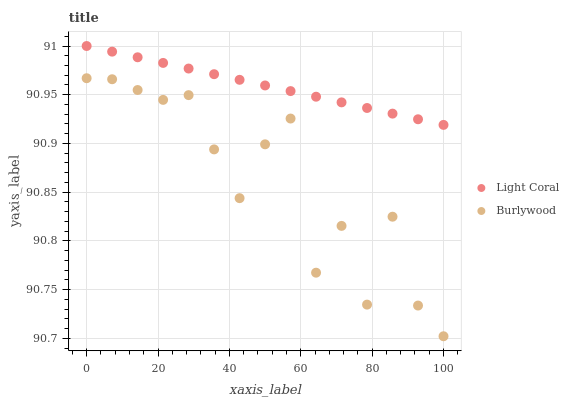Does Burlywood have the minimum area under the curve?
Answer yes or no. Yes. Does Light Coral have the maximum area under the curve?
Answer yes or no. Yes. Does Burlywood have the maximum area under the curve?
Answer yes or no. No. Is Light Coral the smoothest?
Answer yes or no. Yes. Is Burlywood the roughest?
Answer yes or no. Yes. Is Burlywood the smoothest?
Answer yes or no. No. Does Burlywood have the lowest value?
Answer yes or no. Yes. Does Light Coral have the highest value?
Answer yes or no. Yes. Does Burlywood have the highest value?
Answer yes or no. No. Is Burlywood less than Light Coral?
Answer yes or no. Yes. Is Light Coral greater than Burlywood?
Answer yes or no. Yes. Does Burlywood intersect Light Coral?
Answer yes or no. No. 